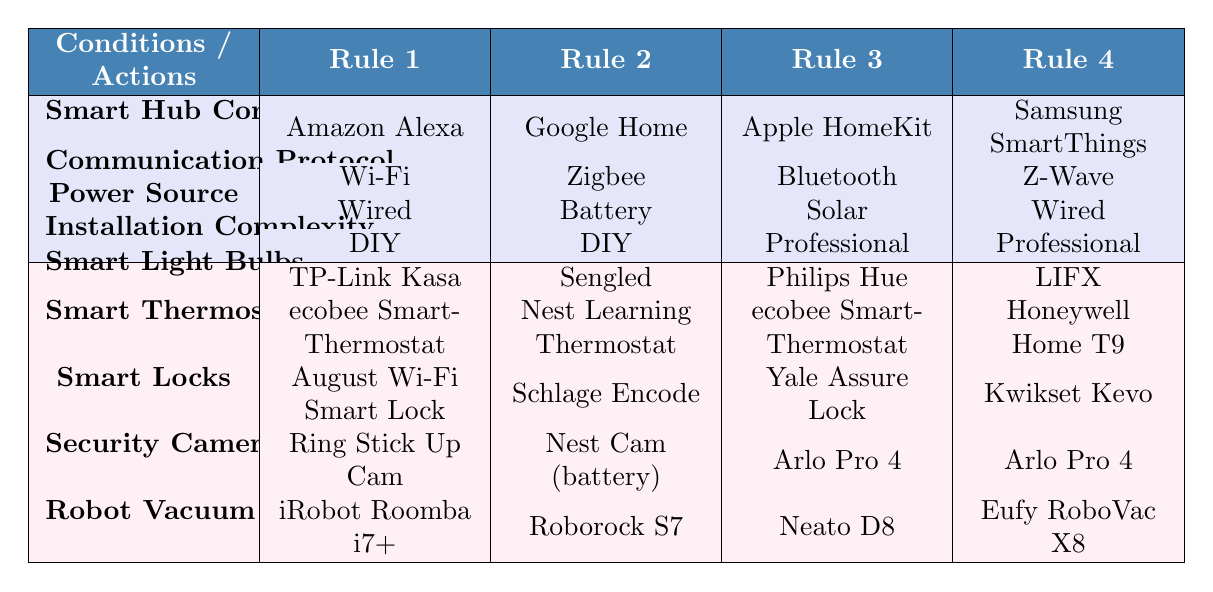What smart light bulb is compatible with Amazon Alexa? The table shows that for the conditions where the smart hub compatibility is Amazon Alexa, the compatible smart light bulb is TP-Link Kasa.
Answer: TP-Link Kasa Which communication protocol is used with Google Home? According to the table, the communication protocol corresponding to Google Home is Zigbee.
Answer: Zigbee Is it possible to use a robot vacuum with Apple HomeKit? Yes, the table indicates that with Apple HomeKit, the robot vacuum compatible is Neato D8, confirming that a robot vacuum can be used.
Answer: Yes How many smart locks are compatible with Samsung SmartThings? The table lists only one smart lock that is compatible with Samsung SmartThings, which is Kwikset Kevo, so the total count is 1.
Answer: 1 What is the power source for the devices compatible with Google Home? Referring to the table, the power source for devices under the conditions of Google Home is Battery.
Answer: Battery Do any devices use Bluetooth as a communication protocol? Yes, the table lists one set of devices (smart light bulbs, thermostats, smart locks, security cameras, and robot vacuum) that can use Bluetooth which is compatible with Apple HomeKit.
Answer: Yes If I want a powered device that requires professional installation, which smart locks can I use? For professional installation, the smart locks available according to the table are Yale Assure Lock and Kwikset Kevo, summing up to 2 options.
Answer: 2 What are the recommended smart thermostats for wired power sources? The table shows that for wired power sources, the recommended smart thermostats are ecobee SmartThermostat for Amazon Alexa and Honeywell Home T9 for Samsung SmartThings.
Answer: ecobee SmartThermostat and Honeywell Home T9 What is the most complex installation requirement across all devices? The table indicates that the most complex installation type is Professional, which is required for devices compatible with both Apple HomeKit and Samsung SmartThings.
Answer: Professional 